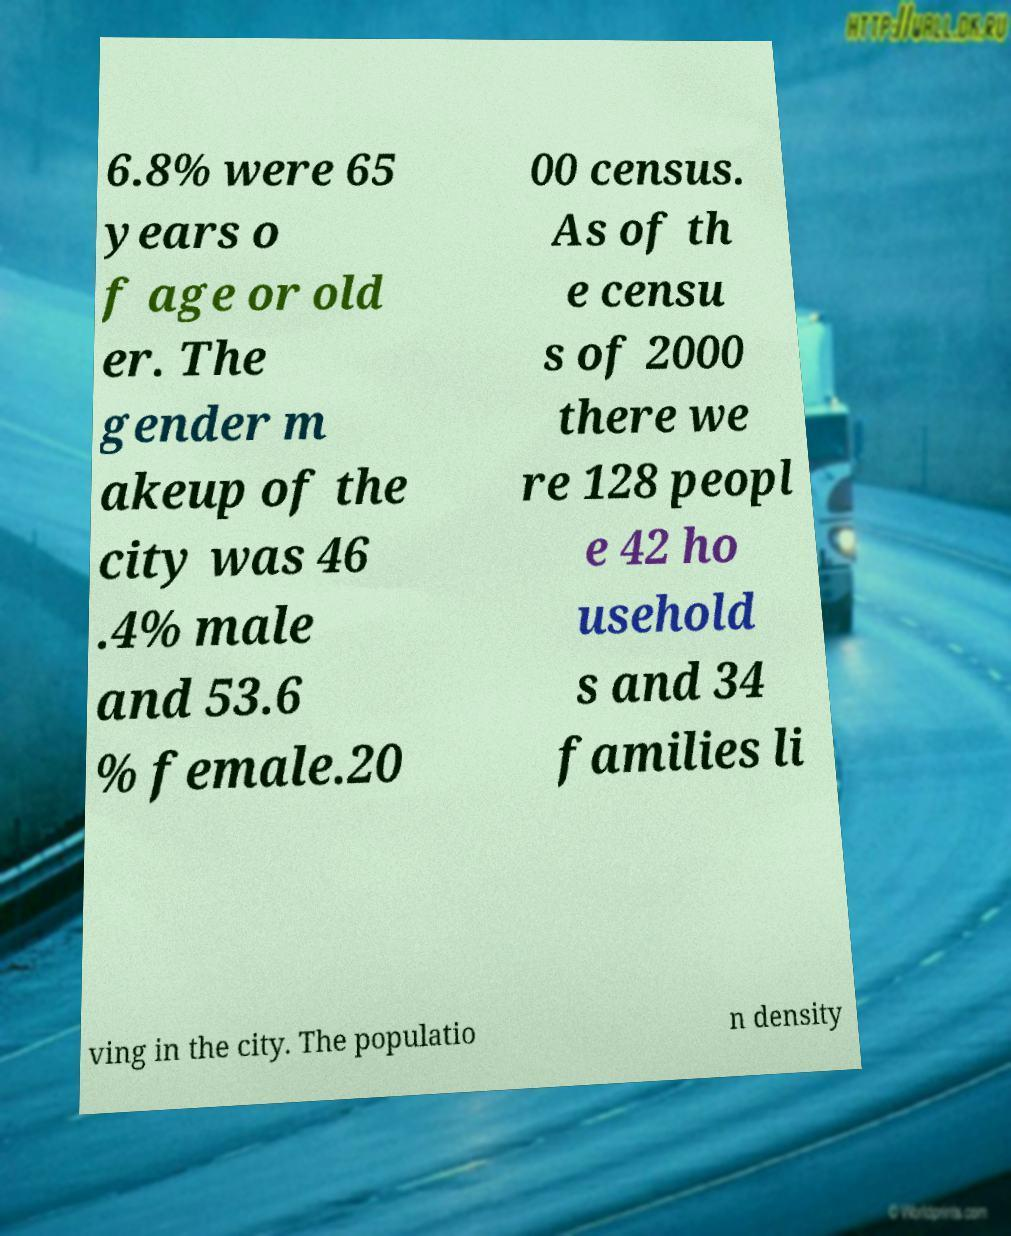What messages or text are displayed in this image? I need them in a readable, typed format. 6.8% were 65 years o f age or old er. The gender m akeup of the city was 46 .4% male and 53.6 % female.20 00 census. As of th e censu s of 2000 there we re 128 peopl e 42 ho usehold s and 34 families li ving in the city. The populatio n density 